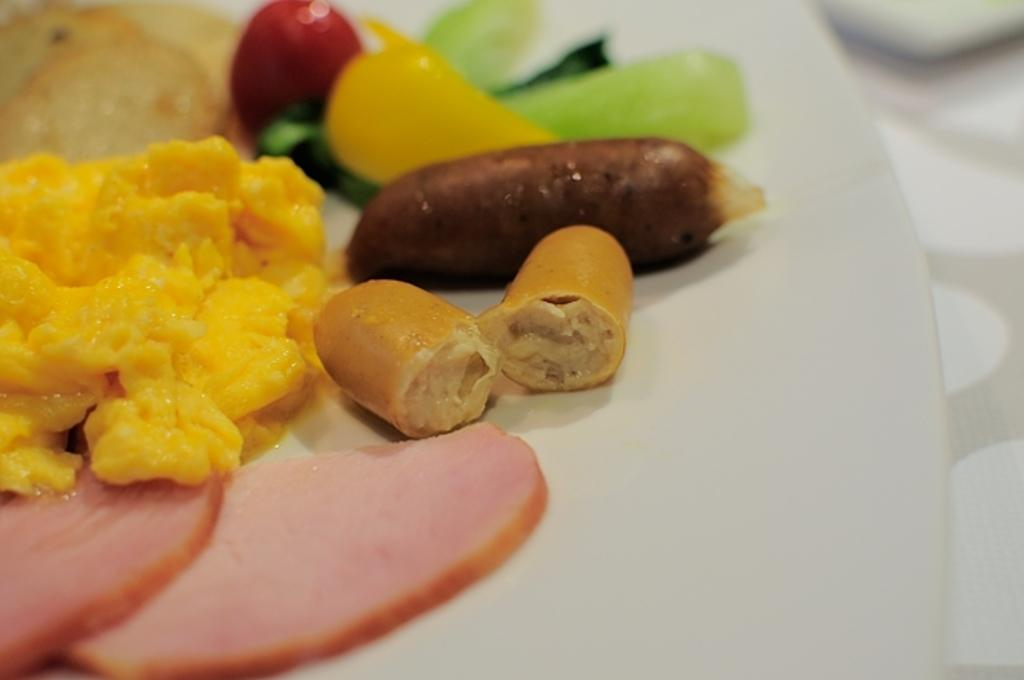What is on the plate in the image? There are food items on the plate in the image. Where is the plate located? The plate is on a platform. Is there a woman cooking meat on a campfire in the image? No, there is no woman or campfire present in the image. The image only shows food items on a plate and the plate on a platform. 